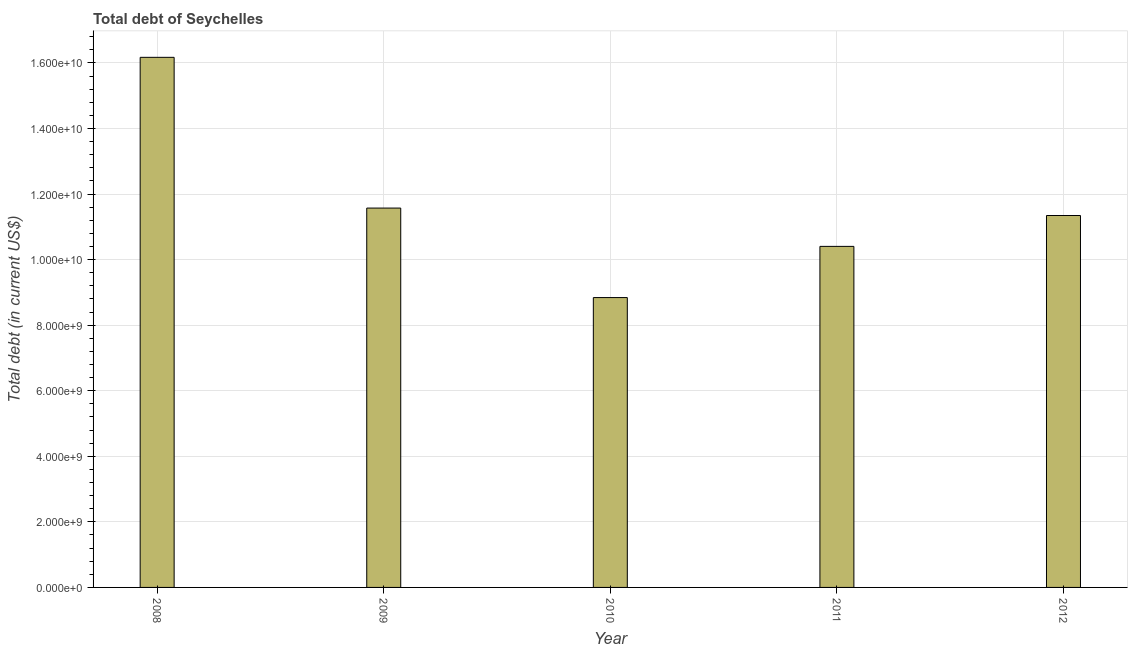What is the title of the graph?
Your response must be concise. Total debt of Seychelles. What is the label or title of the Y-axis?
Your response must be concise. Total debt (in current US$). What is the total debt in 2009?
Provide a succinct answer. 1.16e+1. Across all years, what is the maximum total debt?
Ensure brevity in your answer.  1.62e+1. Across all years, what is the minimum total debt?
Offer a terse response. 8.84e+09. In which year was the total debt maximum?
Keep it short and to the point. 2008. What is the sum of the total debt?
Provide a short and direct response. 5.83e+1. What is the difference between the total debt in 2009 and 2011?
Offer a terse response. 1.17e+09. What is the average total debt per year?
Offer a very short reply. 1.17e+1. What is the median total debt?
Offer a very short reply. 1.13e+1. In how many years, is the total debt greater than 4000000000 US$?
Make the answer very short. 5. Do a majority of the years between 2008 and 2009 (inclusive) have total debt greater than 12400000000 US$?
Provide a short and direct response. No. What is the ratio of the total debt in 2011 to that in 2012?
Provide a succinct answer. 0.92. Is the difference between the total debt in 2008 and 2012 greater than the difference between any two years?
Ensure brevity in your answer.  No. What is the difference between the highest and the second highest total debt?
Your answer should be compact. 4.60e+09. What is the difference between the highest and the lowest total debt?
Ensure brevity in your answer.  7.33e+09. In how many years, is the total debt greater than the average total debt taken over all years?
Provide a succinct answer. 1. How many bars are there?
Your response must be concise. 5. Are all the bars in the graph horizontal?
Provide a short and direct response. No. Are the values on the major ticks of Y-axis written in scientific E-notation?
Your answer should be very brief. Yes. What is the Total debt (in current US$) in 2008?
Ensure brevity in your answer.  1.62e+1. What is the Total debt (in current US$) of 2009?
Offer a terse response. 1.16e+1. What is the Total debt (in current US$) of 2010?
Your answer should be compact. 8.84e+09. What is the Total debt (in current US$) of 2011?
Your answer should be compact. 1.04e+1. What is the Total debt (in current US$) of 2012?
Provide a short and direct response. 1.13e+1. What is the difference between the Total debt (in current US$) in 2008 and 2009?
Your response must be concise. 4.60e+09. What is the difference between the Total debt (in current US$) in 2008 and 2010?
Offer a very short reply. 7.33e+09. What is the difference between the Total debt (in current US$) in 2008 and 2011?
Offer a very short reply. 5.77e+09. What is the difference between the Total debt (in current US$) in 2008 and 2012?
Make the answer very short. 4.83e+09. What is the difference between the Total debt (in current US$) in 2009 and 2010?
Your answer should be compact. 2.73e+09. What is the difference between the Total debt (in current US$) in 2009 and 2011?
Offer a very short reply. 1.17e+09. What is the difference between the Total debt (in current US$) in 2009 and 2012?
Ensure brevity in your answer.  2.27e+08. What is the difference between the Total debt (in current US$) in 2010 and 2011?
Ensure brevity in your answer.  -1.56e+09. What is the difference between the Total debt (in current US$) in 2010 and 2012?
Your response must be concise. -2.50e+09. What is the difference between the Total debt (in current US$) in 2011 and 2012?
Your answer should be compact. -9.42e+08. What is the ratio of the Total debt (in current US$) in 2008 to that in 2009?
Give a very brief answer. 1.4. What is the ratio of the Total debt (in current US$) in 2008 to that in 2010?
Provide a short and direct response. 1.83. What is the ratio of the Total debt (in current US$) in 2008 to that in 2011?
Provide a succinct answer. 1.55. What is the ratio of the Total debt (in current US$) in 2008 to that in 2012?
Give a very brief answer. 1.43. What is the ratio of the Total debt (in current US$) in 2009 to that in 2010?
Ensure brevity in your answer.  1.31. What is the ratio of the Total debt (in current US$) in 2009 to that in 2011?
Make the answer very short. 1.11. What is the ratio of the Total debt (in current US$) in 2010 to that in 2011?
Offer a very short reply. 0.85. What is the ratio of the Total debt (in current US$) in 2010 to that in 2012?
Offer a terse response. 0.78. What is the ratio of the Total debt (in current US$) in 2011 to that in 2012?
Ensure brevity in your answer.  0.92. 